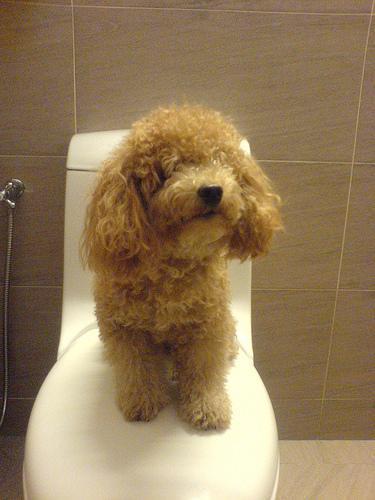How many dogs are in this picture?
Give a very brief answer. 1. 